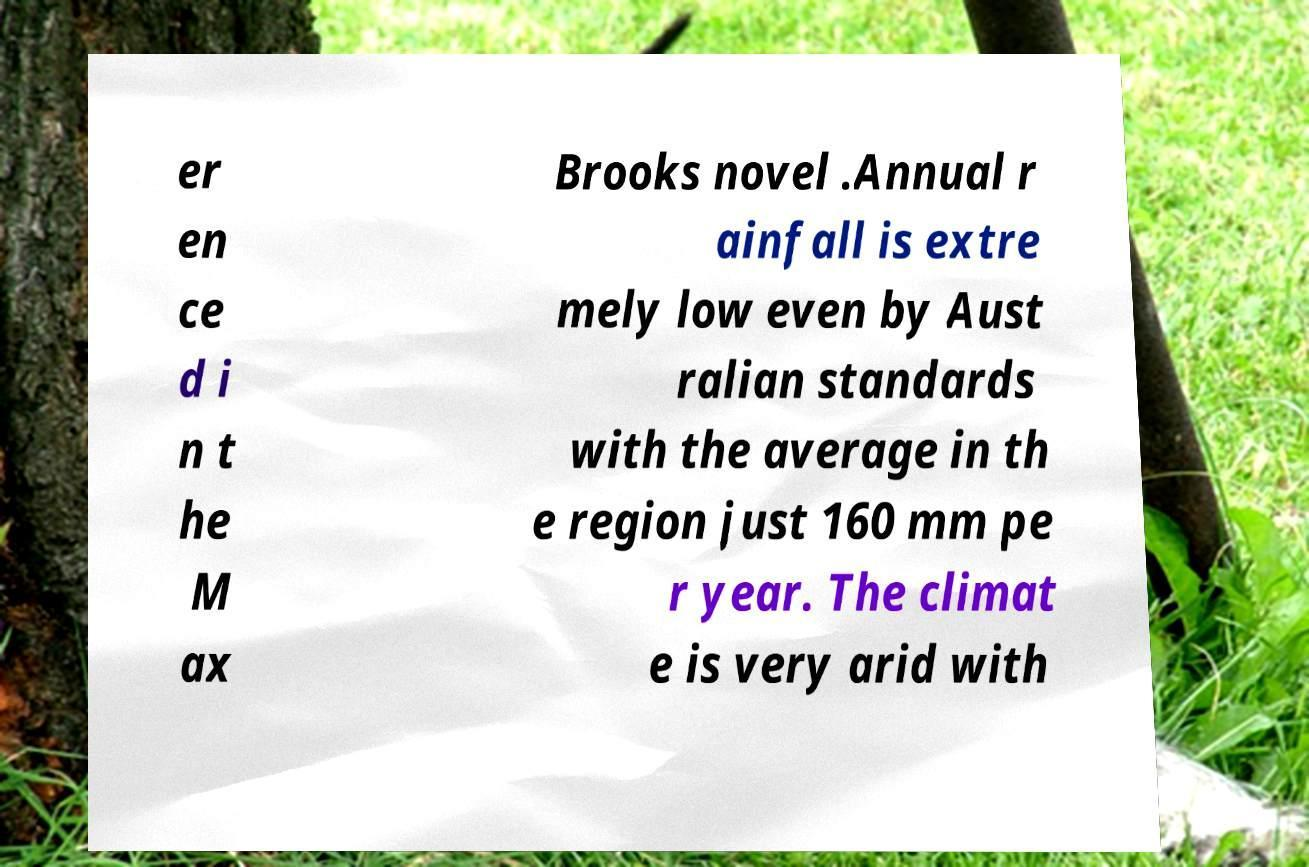What messages or text are displayed in this image? I need them in a readable, typed format. er en ce d i n t he M ax Brooks novel .Annual r ainfall is extre mely low even by Aust ralian standards with the average in th e region just 160 mm pe r year. The climat e is very arid with 